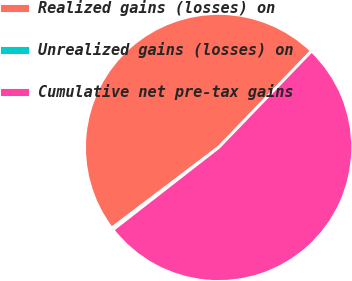Convert chart. <chart><loc_0><loc_0><loc_500><loc_500><pie_chart><fcel>Realized gains (losses) on<fcel>Unrealized gains (losses) on<fcel>Cumulative net pre-tax gains<nl><fcel>47.51%<fcel>0.23%<fcel>52.26%<nl></chart> 